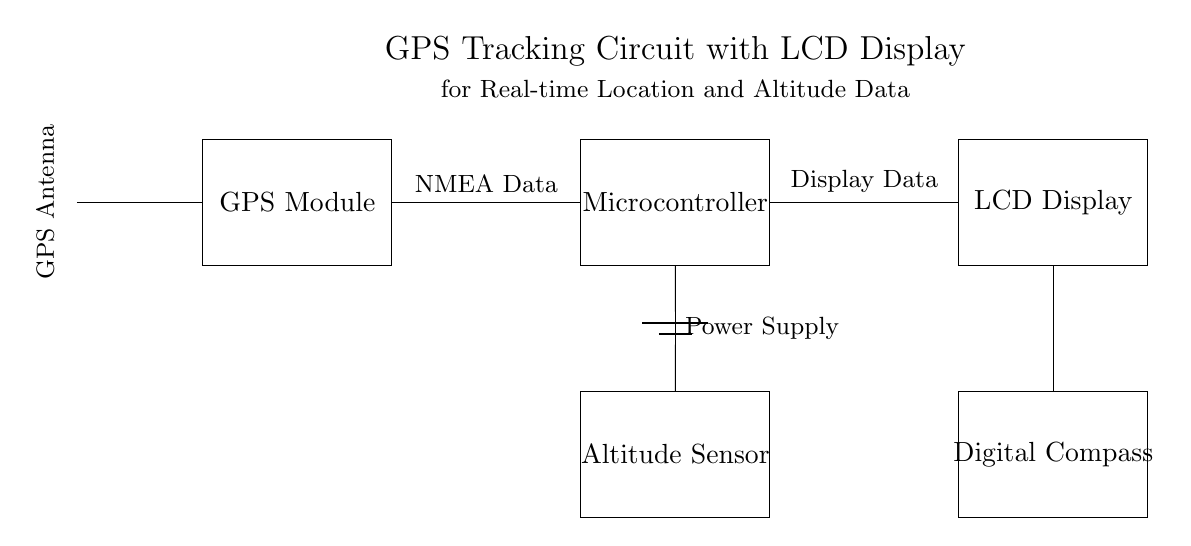What is the main function of the GPS module in this circuit? The GPS module receives signals from satellites to determine the geographical location and altitude.
Answer: location and altitude What does the LCD display show? The LCD display shows the processed data received from the GPS module and altitude sensor, such as real-time location coordinates and altitude.
Answer: real-time location and altitude data How many main components are in the circuit? There are four main components: GPS module, microcontroller, LCD display, altitude sensor, and digital compass.
Answer: four What is the purpose of the antenna in the circuit? The antenna receives GPS signals from satellites, which are essential for determining location.
Answer: receive GPS signals What connections exist in the circuit? The GPS module connects to the microcontroller, which then connects to the LCD display and altitude sensor, while the power supply connects to both the microcontroller and altitude sensor.
Answer: GPS to microcontroller, microcontroller to LCD, microcontroller to altitude sensor Explain how data is transferred from the GPS module to the LCD display. The GPS module processes the satellite signals, sends the NMEA data to the microcontroller, which then processes and sends the formatted data to the LCD display to show the real-time coordinates.
Answer: From GPS module to microcontroller to LCD display What is the role of the power supply in this circuit? The power supply provides the necessary voltage and current to the microcontroller and other components to operate them effectively.
Answer: to provide power 